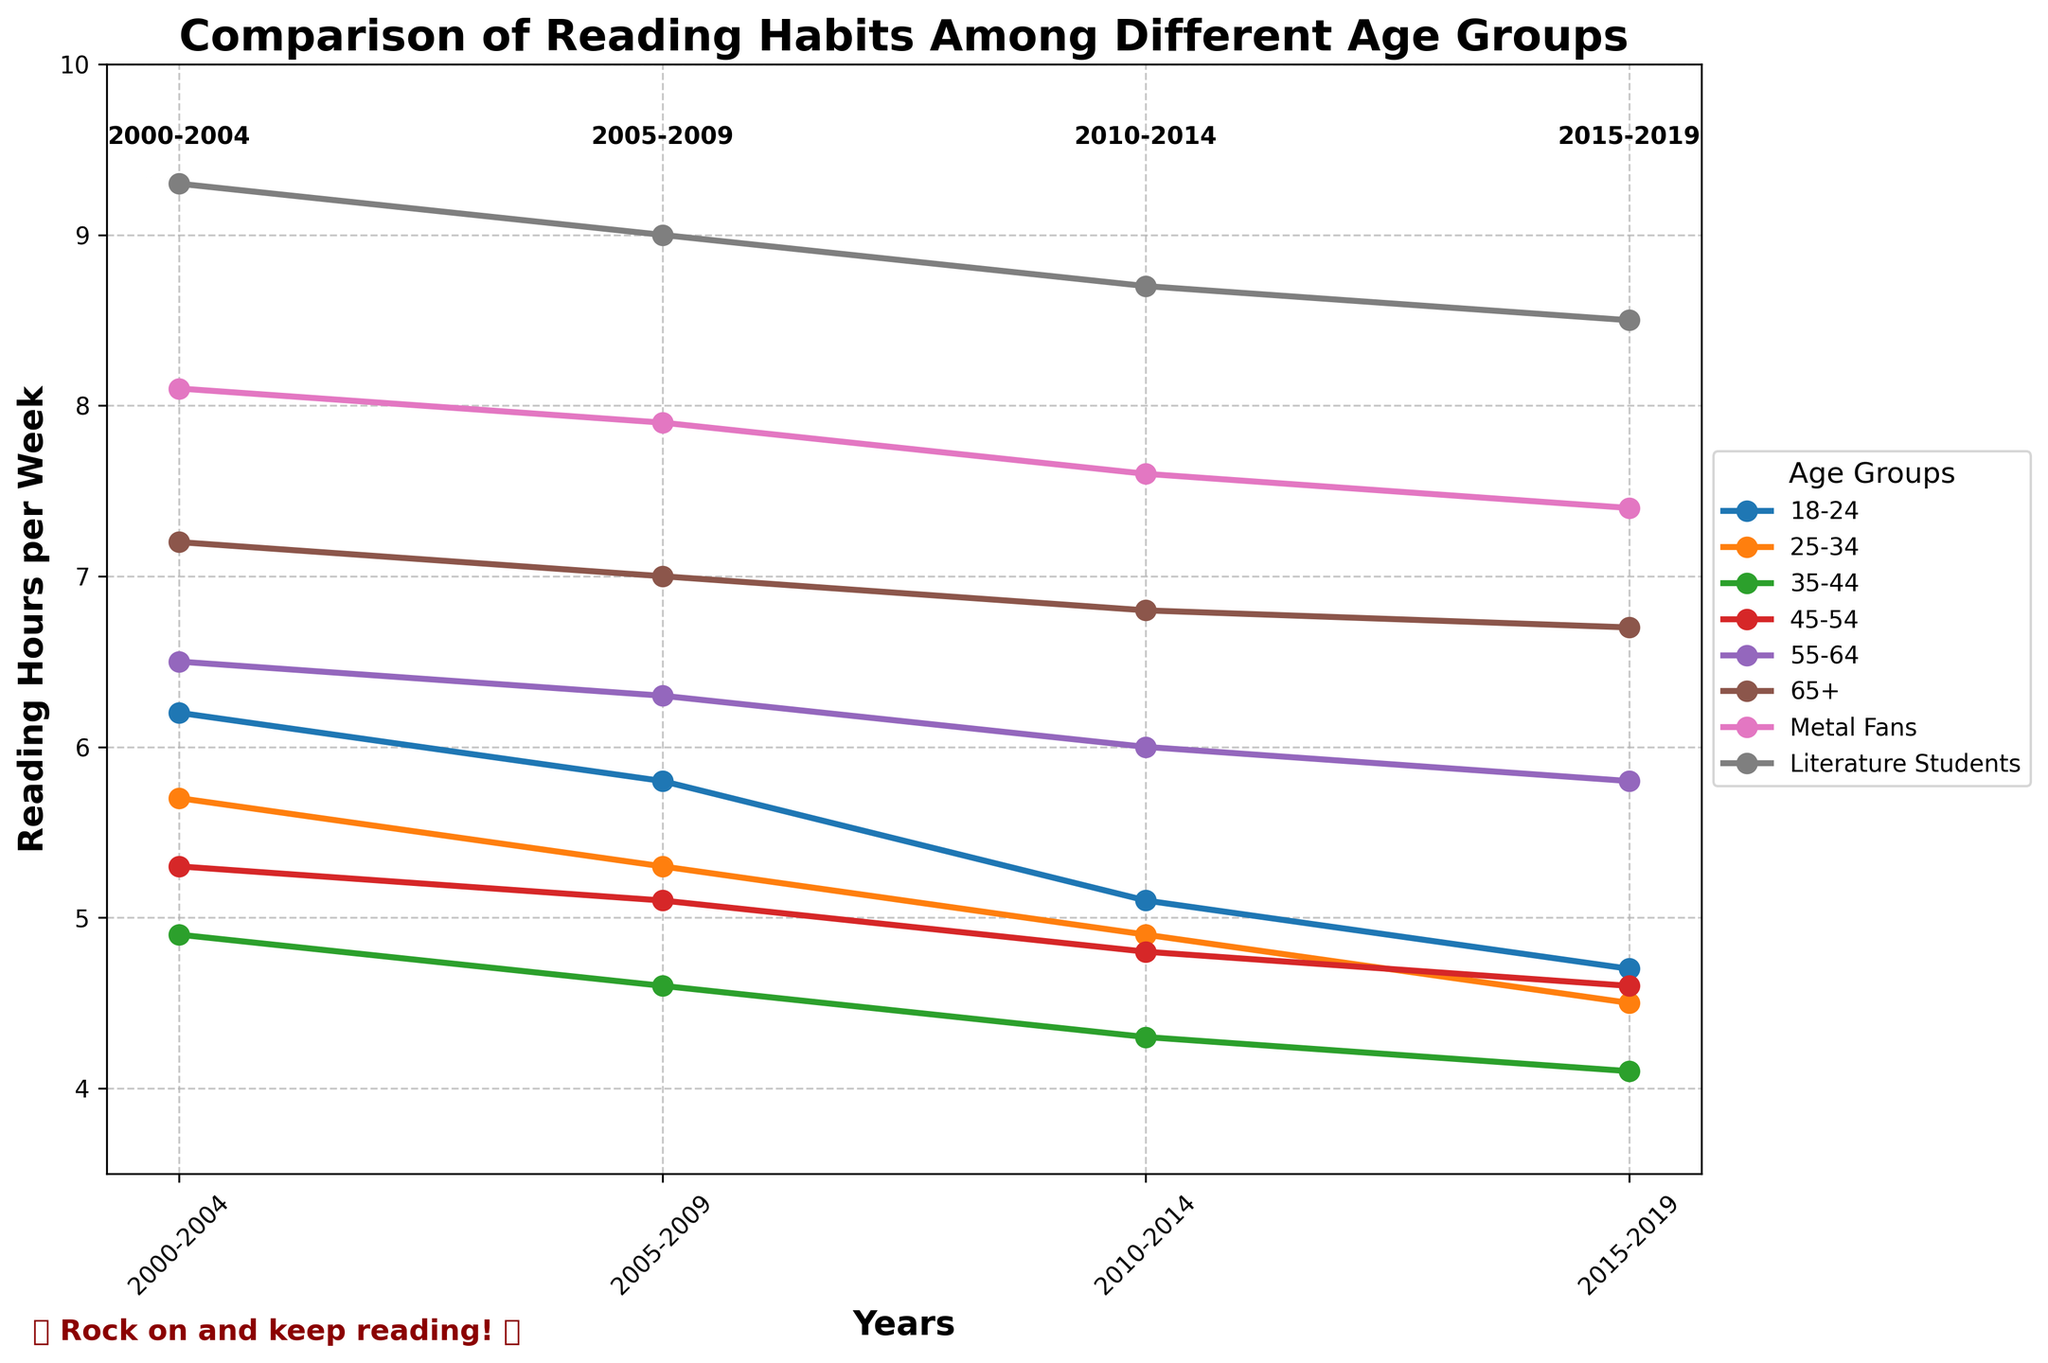What is the trend in reading hours for the age group 18-24 from 2000 to 2019? The reading hours for the age group 18-24 have consistently decreased over the years. In 2000-2004, it was 6.2 hours per week, but by 2015-2019, it decreased to 4.7 hours per week.
Answer: Decreasing Which age group had the highest reading hours consistently over the two decades? The "Literature Students" category consistently had the highest reading hours every decade.
Answer: Literature Students How much did the reading hours decrease for the 55-64 age group from 2000-2004 to 2015-2019? Reading hours decreased from 6.5 in 2000-2004 to 5.8 in 2015-2019. Subtracting 5.8 from 6.5 gives a decrease of 0.7 hours.
Answer: 0.7 hours Which group showed the smallest decline in reading hours over the two decades? The "65+" group showed the smallest decline, dropping from 7.2 to 6.7, a decrease of only 0.5 hours.
Answer: 65+ What is the average reading hours for the 25-34 age group over the four periods? Add up all the values for the 25-34 age group (5.7 + 5.3 + 4.9 + 4.5) which equals 20.4. Divide by 4 to find the average: 20.4/4 = 5.1.
Answer: 5.1 hours Which two age groups had similar reading habits in 2015-2019? The 18-24 and 25-34 age groups had similar reading habits in 2015-2019, reading 4.7 and 4.5 hours per week respectively.
Answer: 18-24 and 25-34 By how many hours did the reading habits of metal fans decrease from 2000-2004 to 2015-2019? The reading hours for metal fans decreased from 8.1 to 7.4. Subtracting 7.4 from 8.1 gives a decrease of 0.7 hours.
Answer: 0.7 hours Is there a correlation between age and reading hours, and if so, what is it? There appears to be a negative correlation between age and reading hours. As age increases, reading hours tend to decrease, though the "65+" category is an exception with consistently high readings.
Answer: Negative correlation Which group had the highest percentage decline in reading hours from 2000-2004 to 2015-2019? The 18-24 age group had the highest percentage decline. It went from 6.2 to 4.7 hours. The percentage decline is ((6.2 - 4.7)/6.2) * 100 = 24.19%.
Answer: 18-24 What is the median reading hours for the age group 45-54 across all periods? List the values for 45-54 (5.3, 5.1, 4.8, 4.6), then find the median. The median of (5.3, 5.1, 4.8, 4.6) is the average of 5.1 and 4.8, which is (5.1 + 4.8)/2 = 4.95.
Answer: 4.95 hours 